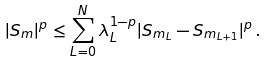Convert formula to latex. <formula><loc_0><loc_0><loc_500><loc_500>| S _ { m } | ^ { p } \leq \sum _ { L = 0 } ^ { N } \lambda _ { L } ^ { 1 - p } | S _ { m _ { L } } - S _ { m _ { L + 1 } } | ^ { p } \, .</formula> 